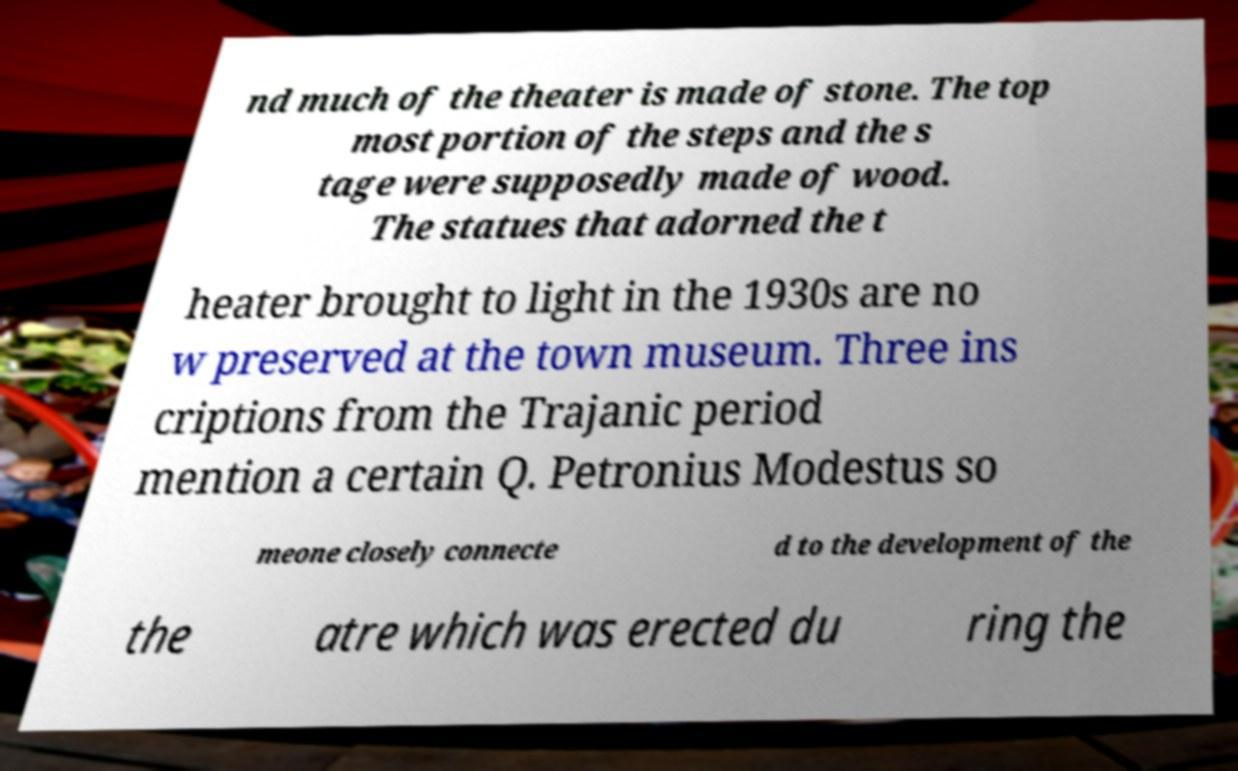Please read and relay the text visible in this image. What does it say? nd much of the theater is made of stone. The top most portion of the steps and the s tage were supposedly made of wood. The statues that adorned the t heater brought to light in the 1930s are no w preserved at the town museum. Three ins criptions from the Trajanic period mention a certain Q. Petronius Modestus so meone closely connecte d to the development of the the atre which was erected du ring the 